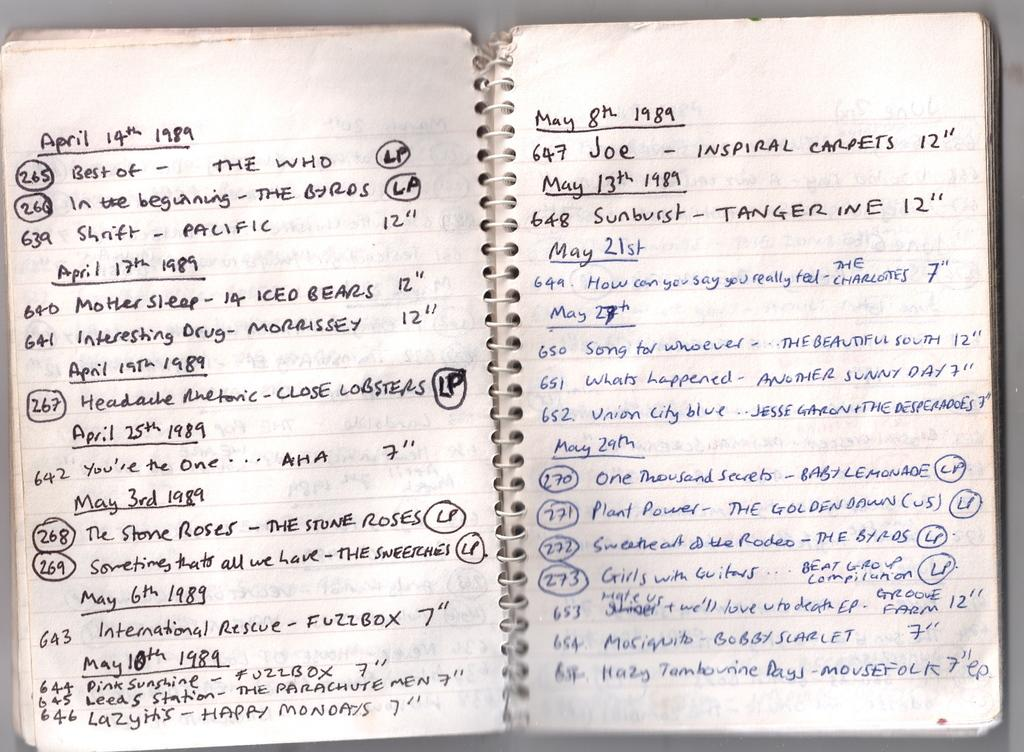What type of object is the main subject of the image? The object is a book. What is unique about the binding of the book? The book has a spring binding. What can be found inside the book? There are letters and numbers written in the book. Are there any additional materials associated with the book? Yes, there are papers associated with the book. Can you see a tramp performing acrobatics in the image? No, there is no tramp performing acrobatics in the image; it features a book with a spring binding and associated papers. What type of fruit is being used as a tent in the image? There is no fruit or tent present in the image; it only contains a book with a spring binding and associated papers. 